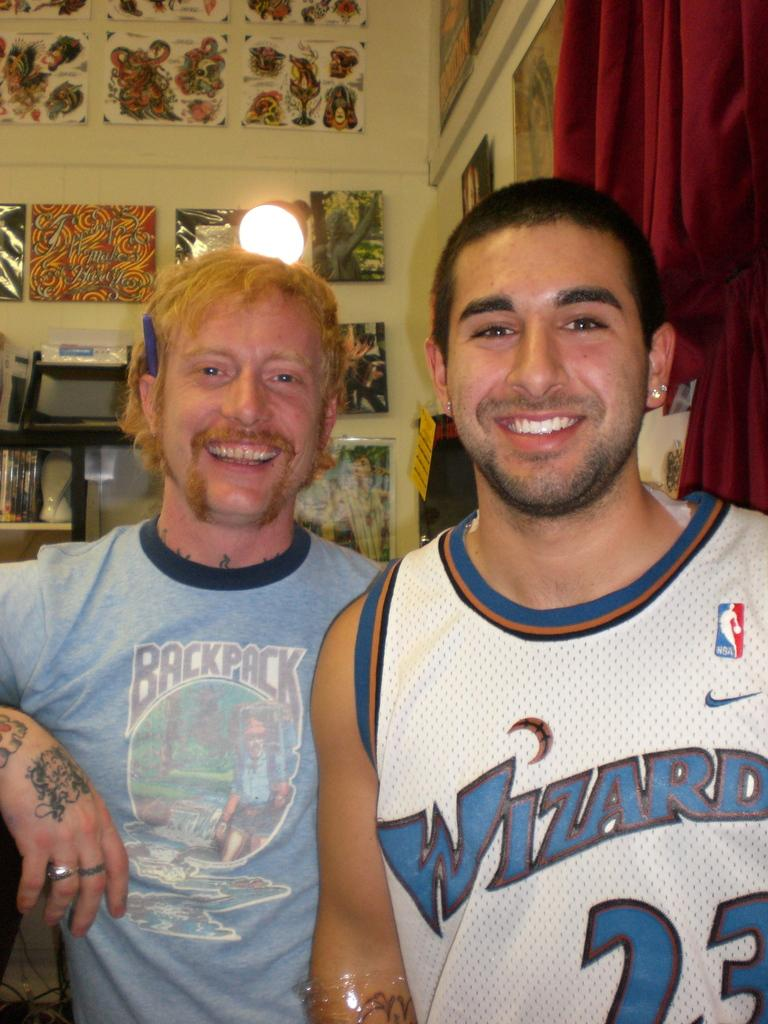<image>
Provide a brief description of the given image. two men smiling for the camera with one wearing a wizard jersey 